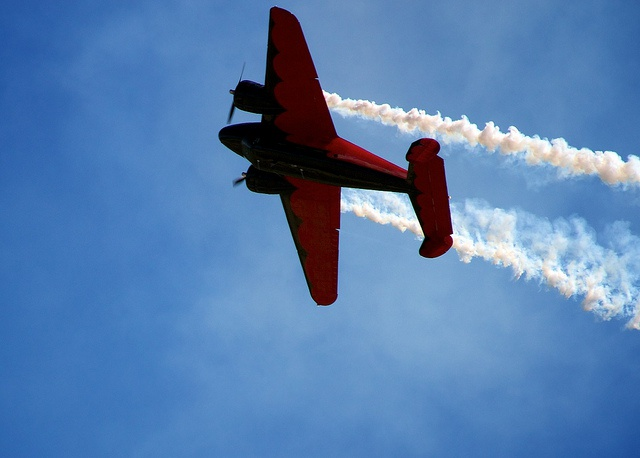Describe the objects in this image and their specific colors. I can see a airplane in blue, black, maroon, darkgray, and gray tones in this image. 